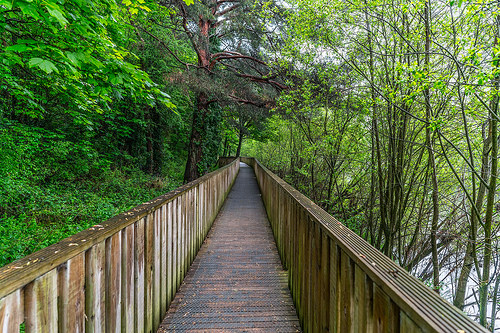<image>
Is there a bridge behind the tree? No. The bridge is not behind the tree. From this viewpoint, the bridge appears to be positioned elsewhere in the scene. 